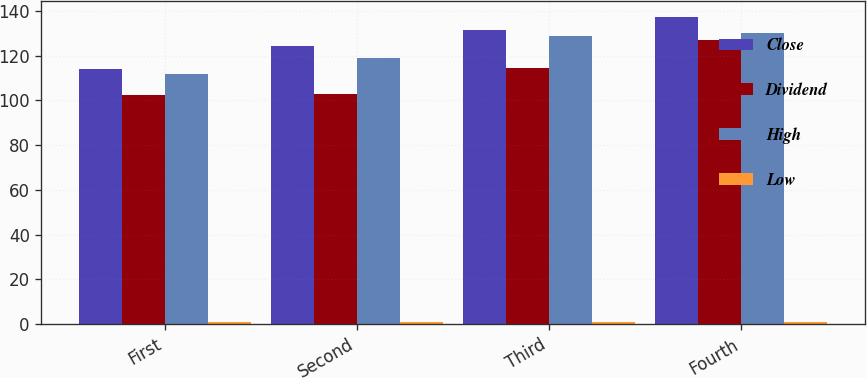Convert chart. <chart><loc_0><loc_0><loc_500><loc_500><stacked_bar_chart><ecel><fcel>First<fcel>Second<fcel>Third<fcel>Fourth<nl><fcel>Close<fcel>113.99<fcel>124.4<fcel>131.48<fcel>137.45<nl><fcel>Dividend<fcel>102.23<fcel>102.73<fcel>114.28<fcel>126.82<nl><fcel>High<fcel>111.78<fcel>119.04<fcel>128.62<fcel>130.18<nl><fcel>Low<fcel>0.71<fcel>0.77<fcel>0.77<fcel>0.77<nl></chart> 